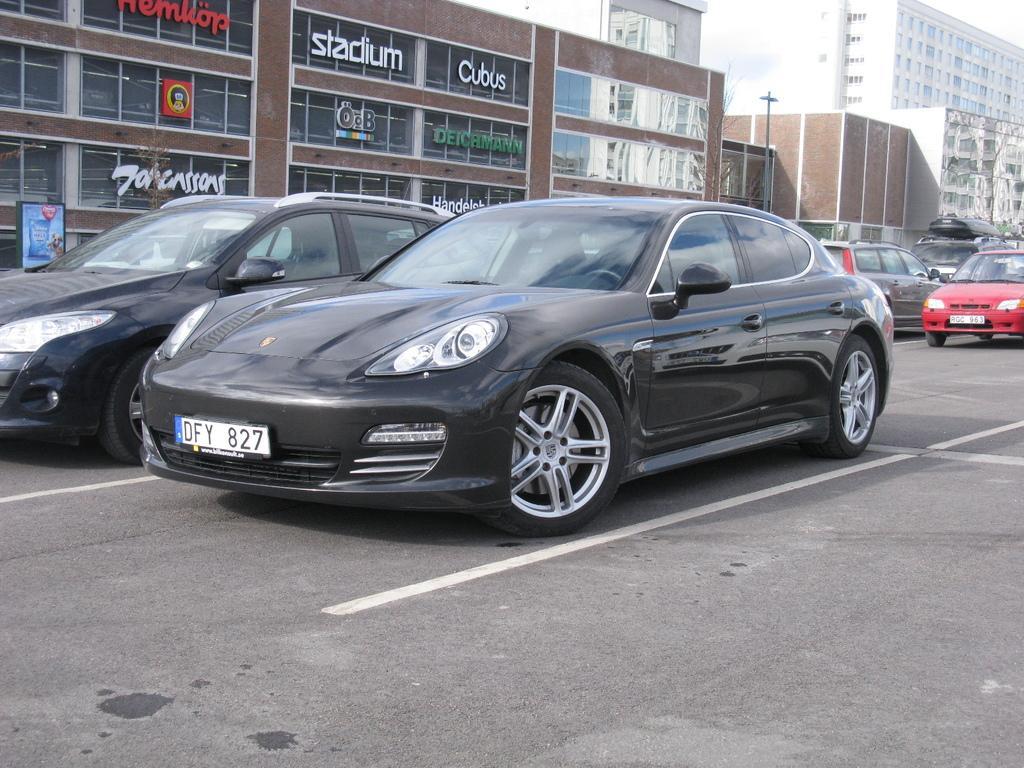Can you describe this image briefly? At the left side of the picture we can see buildings. Here we can see vehicles on the road. This is a blue board. 